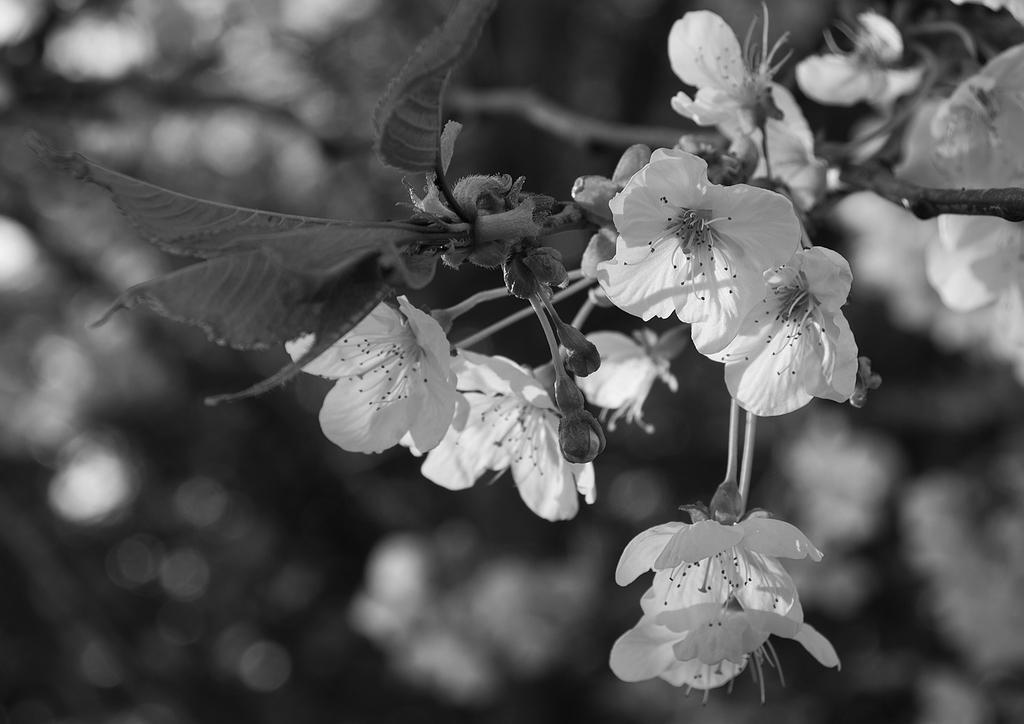How would you summarize this image in a sentence or two? This is a black and white image. On the right side, there are branches of a tree having leaves, fruits and flowers. And the background is blurred. 